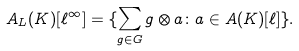Convert formula to latex. <formula><loc_0><loc_0><loc_500><loc_500>A _ { L } ( K ) [ \ell ^ { \infty } ] = \{ \sum _ { g \in G } g \otimes a \colon a \in A ( K ) [ \ell ] \} .</formula> 